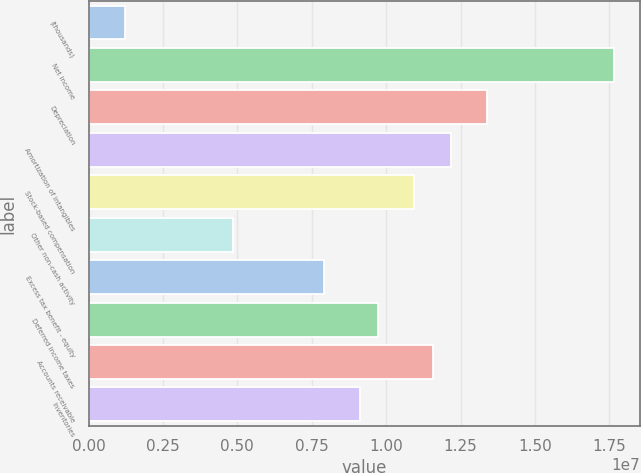Convert chart. <chart><loc_0><loc_0><loc_500><loc_500><bar_chart><fcel>(thousands)<fcel>Net income<fcel>Depreciation<fcel>Amortization of intangibles<fcel>Stock-based compensation<fcel>Other non-cash activity<fcel>Excess tax benefit - equity<fcel>Deferred income taxes<fcel>Accounts receivable<fcel>Inventories<nl><fcel>1.2172e+06<fcel>1.76426e+07<fcel>1.33842e+07<fcel>1.21675e+07<fcel>1.09508e+07<fcel>4.8673e+06<fcel>7.90905e+06<fcel>9.7341e+06<fcel>1.15591e+07<fcel>9.12575e+06<nl></chart> 